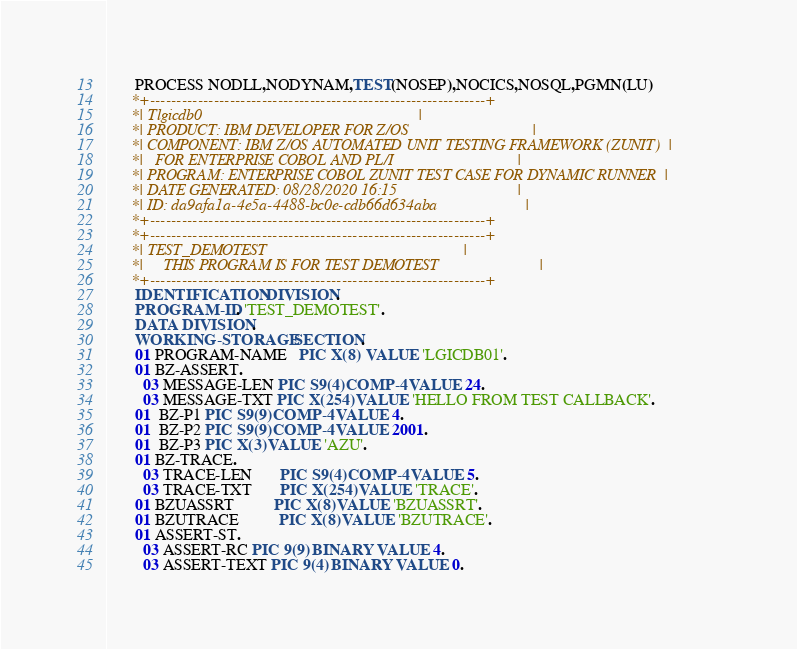<code> <loc_0><loc_0><loc_500><loc_500><_COBOL_>       PROCESS NODLL,NODYNAM,TEST(NOSEP),NOCICS,NOSQL,PGMN(LU)
      *+---------------------------------------------------------------+
      *| Tlgicdb0                                                      |
      *| PRODUCT: IBM DEVELOPER FOR Z/OS                               |
      *| COMPONENT: IBM Z/OS AUTOMATED UNIT TESTING FRAMEWORK (ZUNIT)  |
      *|   FOR ENTERPRISE COBOL AND PL/I                               |
      *| PROGRAM: ENTERPRISE COBOL ZUNIT TEST CASE FOR DYNAMIC RUNNER  |
      *| DATE GENERATED: 08/28/2020 16:15                              |
      *| ID: da9afa1a-4e5a-4488-bc0e-cdb66d634aba                      |
      *+---------------------------------------------------------------+
      *+---------------------------------------------------------------+
      *| TEST_DEMOTEST                                                 |
      *|     THIS PROGRAM IS FOR TEST DEMOTEST                         |
      *+---------------------------------------------------------------+
       IDENTIFICATION DIVISION.
       PROGRAM-ID. 'TEST_DEMOTEST'.
       DATA DIVISION.
       WORKING-STORAGE SECTION.
       01 PROGRAM-NAME   PIC X(8)  VALUE 'LGICDB01'.
       01 BZ-ASSERT.
         03 MESSAGE-LEN PIC S9(4) COMP-4 VALUE 24.
         03 MESSAGE-TXT PIC X(254) VALUE 'HELLO FROM TEST CALLBACK'.
       01  BZ-P1 PIC S9(9) COMP-4 VALUE 4.
       01  BZ-P2 PIC S9(9) COMP-4 VALUE 2001.
       01  BZ-P3 PIC X(3) VALUE 'AZU'.
       01 BZ-TRACE.
         03 TRACE-LEN       PIC S9(4) COMP-4 VALUE 5.
         03 TRACE-TXT       PIC X(254) VALUE 'TRACE'.
       01 BZUASSRT          PIC X(8) VALUE 'BZUASSRT'.
       01 BZUTRACE          PIC X(8) VALUE 'BZUTRACE'.
       01 ASSERT-ST.
         03 ASSERT-RC PIC 9(9) BINARY VALUE 4.
         03 ASSERT-TEXT PIC 9(4) BINARY VALUE 0.</code> 